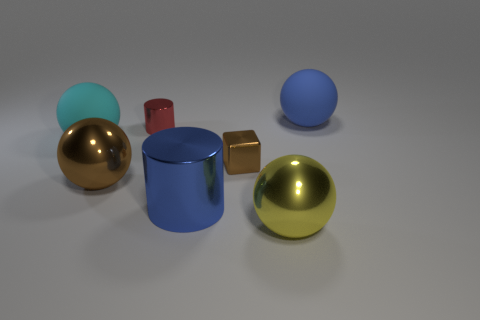Is the number of big things on the right side of the large yellow object less than the number of small shiny things that are on the left side of the blue rubber ball?
Your answer should be compact. Yes. How many blue objects are big metallic spheres or cylinders?
Give a very brief answer. 1. Is the number of brown things behind the big cyan ball the same as the number of cyan metallic balls?
Make the answer very short. Yes. How many objects are tiny matte cylinders or spheres to the right of the big brown shiny object?
Your answer should be compact. 2. Are there any brown spheres that have the same material as the small red cylinder?
Provide a succinct answer. Yes. The other large metallic object that is the same shape as the yellow thing is what color?
Keep it short and to the point. Brown. Are the red cylinder and the blue thing that is behind the cyan object made of the same material?
Offer a very short reply. No. What is the shape of the large blue thing that is to the right of the tiny brown shiny object that is to the right of the small metal cylinder?
Offer a terse response. Sphere. There is a shiny cylinder in front of the cyan sphere; is its size the same as the red cylinder?
Provide a short and direct response. No. How many other objects are there of the same shape as the blue rubber thing?
Make the answer very short. 3. 